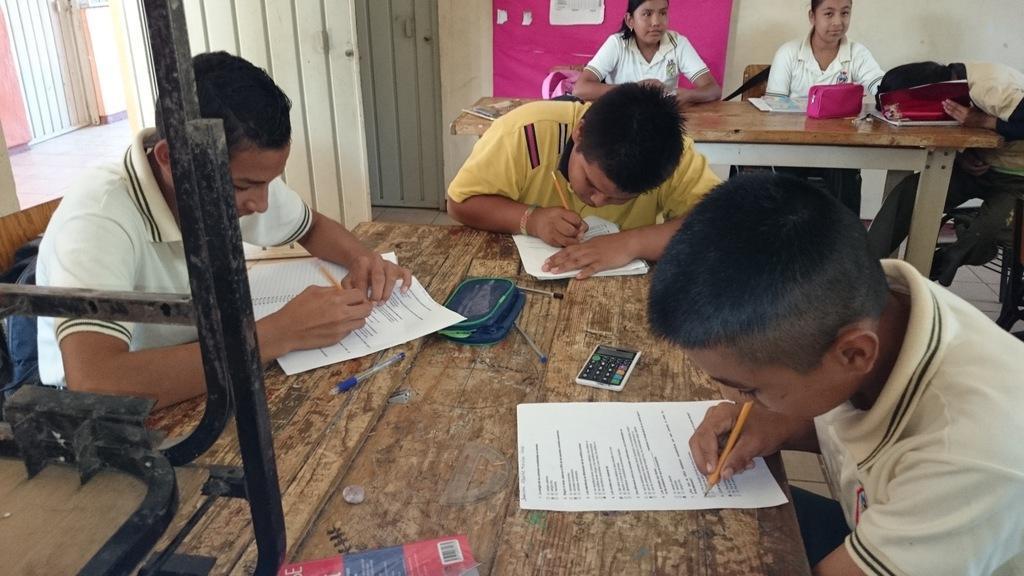How would you summarize this image in a sentence or two? In the foreground of this image, there are three boys sitting near a table and holding pencils. On the table, there are papers, books, pouch, pens, eraser and a calculator. On the left, there is an object. In the background, there are three persons sitting near a table on which, there are books and a pouch. There are also doors, floor, a board and the wall. 